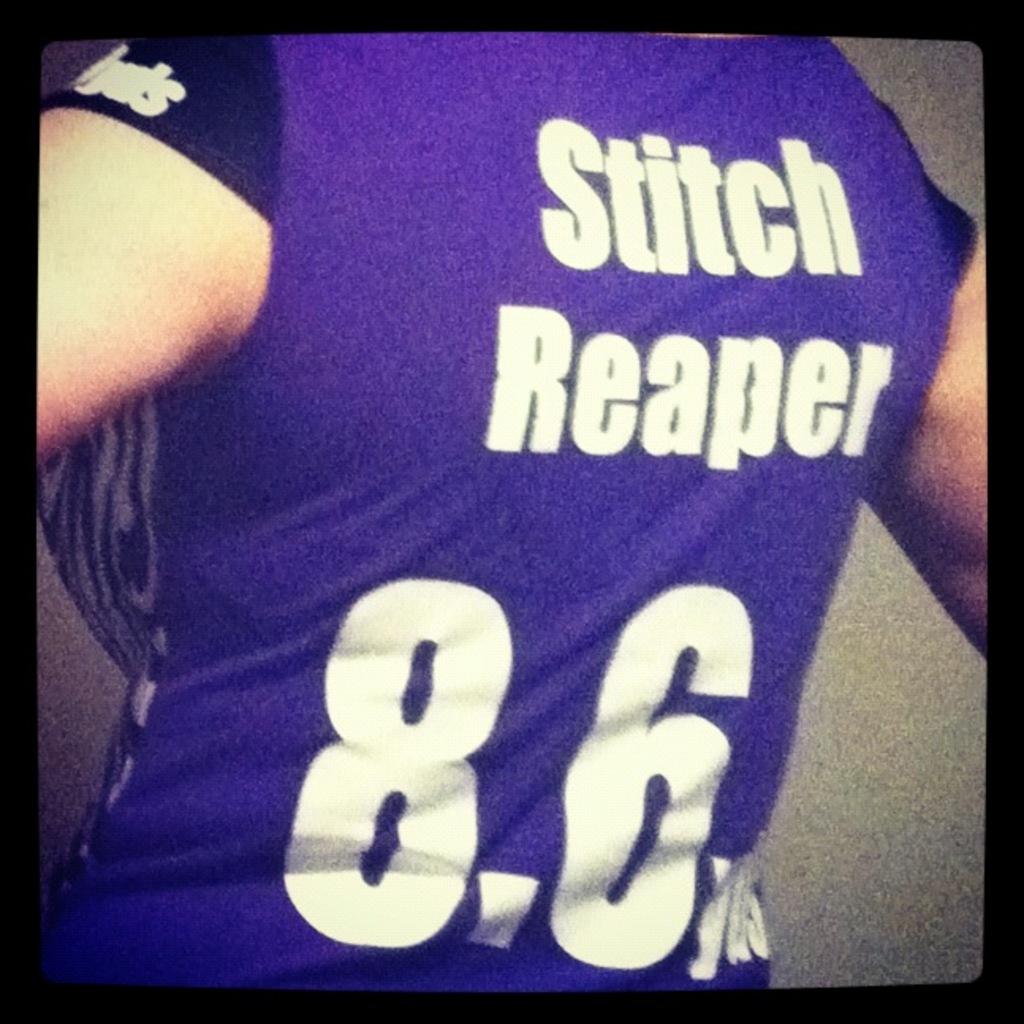What number is on their jersey?
Keep it short and to the point. 8.6. 